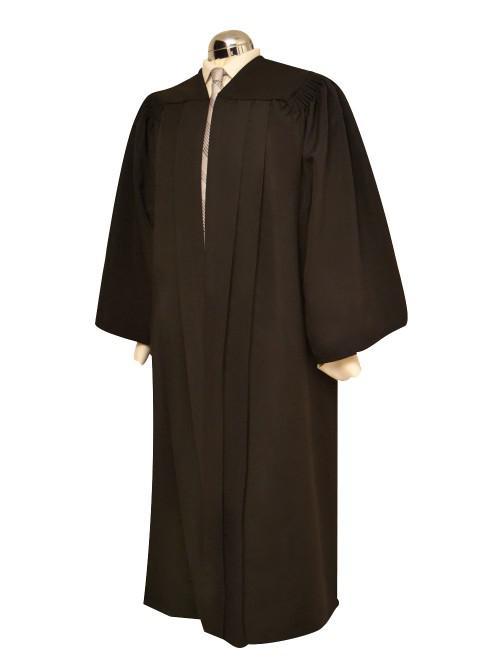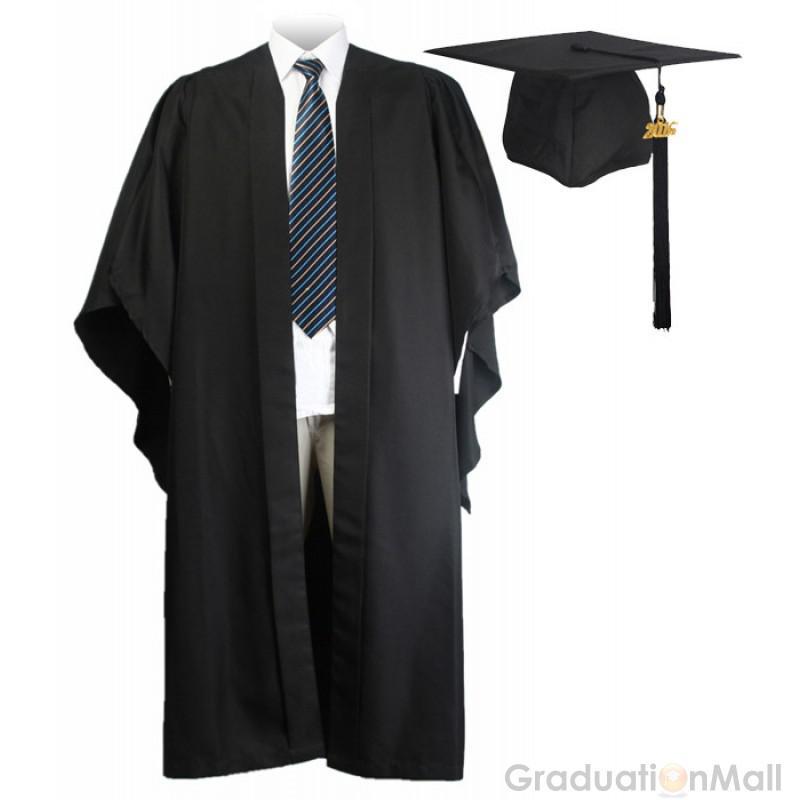The first image is the image on the left, the second image is the image on the right. For the images shown, is this caption "An image shows a black graduation robe with bright blue around the collar, and the other image shows an unworn solid-colored gown." true? Answer yes or no. No. 